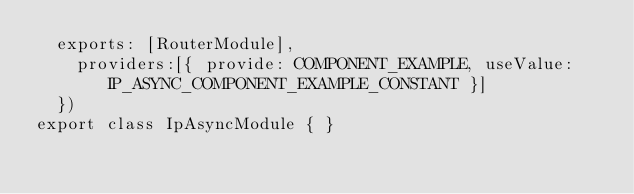Convert code to text. <code><loc_0><loc_0><loc_500><loc_500><_TypeScript_>  exports: [RouterModule],
    providers:[{ provide: COMPONENT_EXAMPLE, useValue: IP_ASYNC_COMPONENT_EXAMPLE_CONSTANT }]
  })
export class IpAsyncModule { }



</code> 